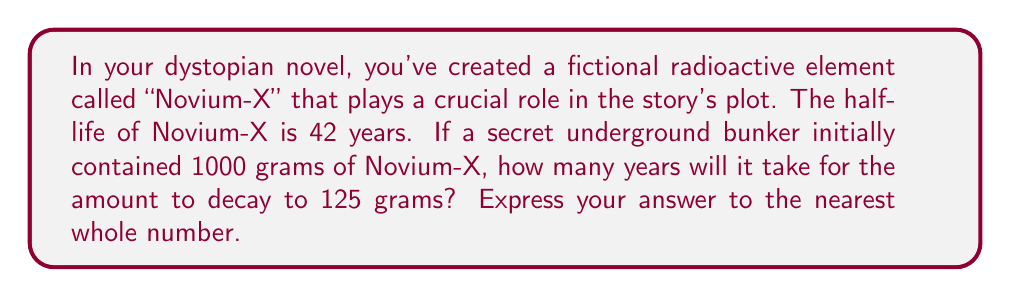Help me with this question. To solve this problem, we'll use the exponential decay formula and then apply logarithms. Let's break it down step-by-step:

1) The exponential decay formula is:

   $$A(t) = A_0 \cdot (1/2)^{t/t_{1/2}}$$

   Where:
   $A(t)$ is the amount remaining after time $t$
   $A_0$ is the initial amount
   $t_{1/2}$ is the half-life
   $t$ is the time we're solving for

2) We know:
   $A_0 = 1000$ grams
   $A(t) = 125$ grams
   $t_{1/2} = 42$ years

3) Let's substitute these into our equation:

   $$125 = 1000 \cdot (1/2)^{t/42}$$

4) Divide both sides by 1000:

   $$0.125 = (1/2)^{t/42}$$

5) Now, let's apply logarithms to both sides. We'll use base 2 logarithms for simplicity:

   $$\log_2(0.125) = \log_2((1/2)^{t/42})$$

6) Using the logarithm property $\log_a(x^n) = n\log_a(x)$:

   $$\log_2(0.125) = (t/42) \cdot \log_2(1/2)$$

7) Simplify: $\log_2(1/2) = -1$ and $\log_2(0.125) = -3$

   $$-3 = -t/42$$

8) Multiply both sides by -42:

   $$126 = t$$

Therefore, it will take 126 years for the Novium-X to decay from 1000 grams to 125 grams.
Answer: 126 years 